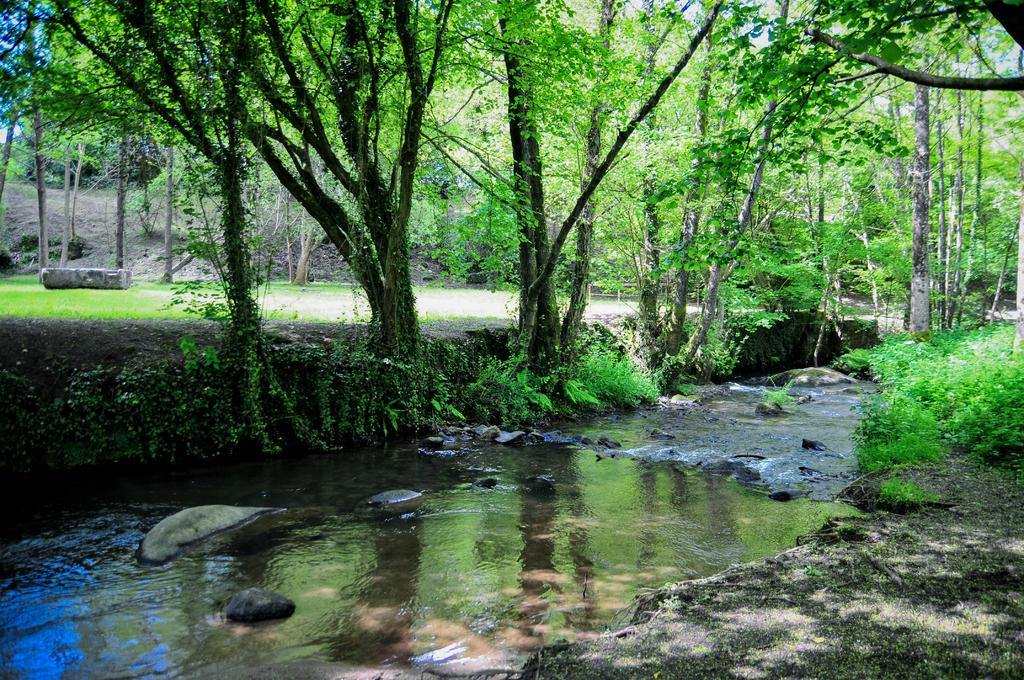What is the primary element visible in the image? There is water in the image. What is located on the water? There are rocks on the water. What type of vegetation is present in front of the water? There are plants in front of the water. What can be seen behind the water? There are many trees behind the water. What type of authority figure can be seen in the image? There is no authority figure present in the image. How does the sponge absorb water in the image? There is no sponge present in the image. 